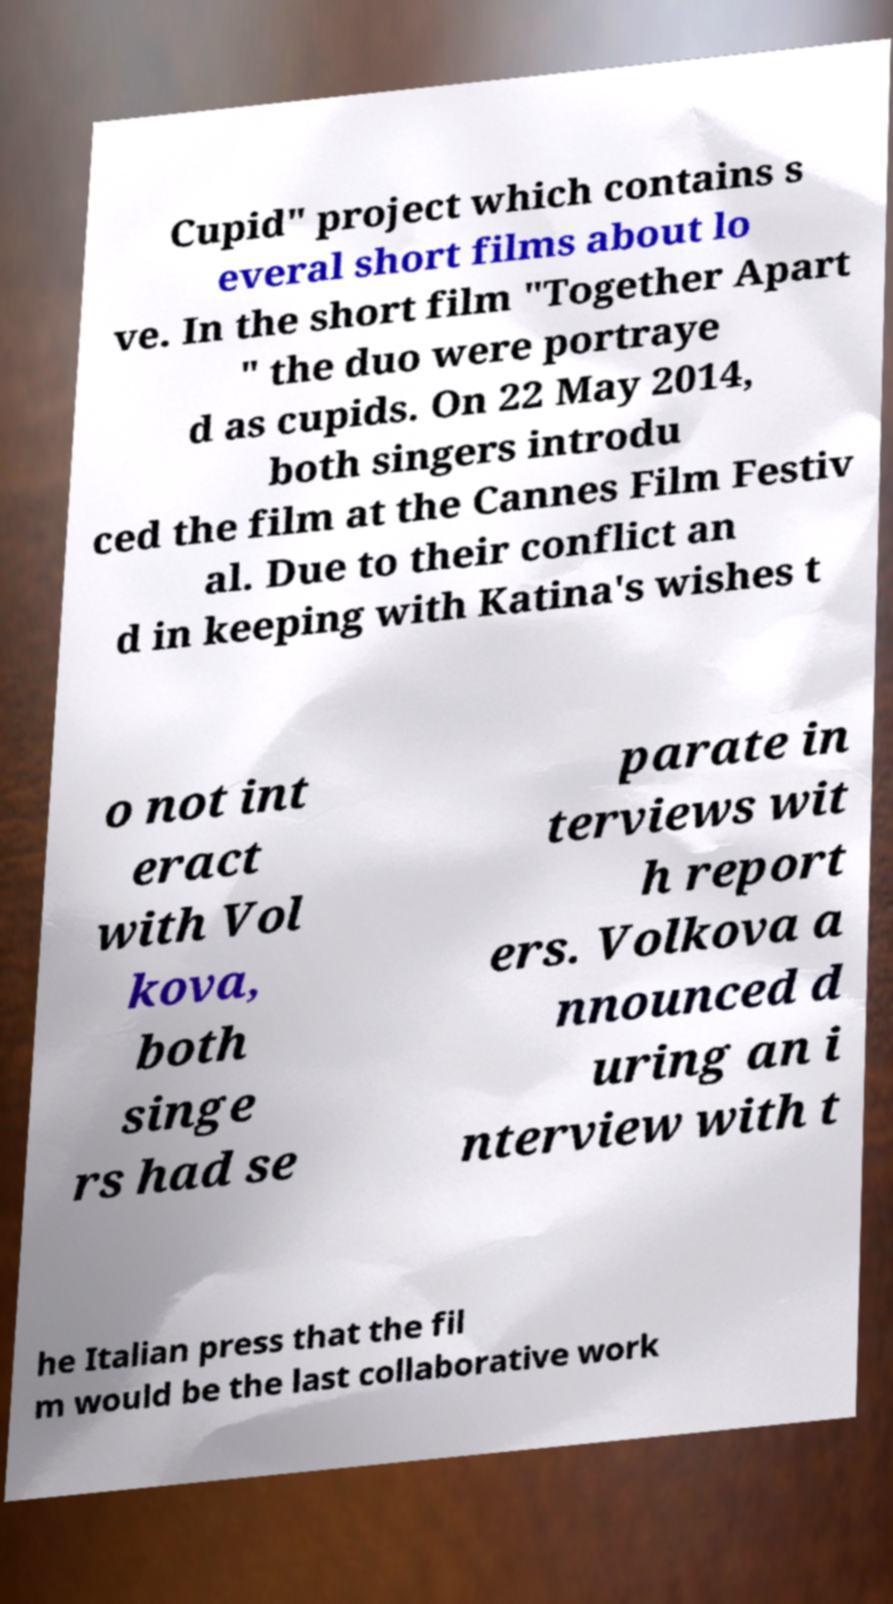Can you read and provide the text displayed in the image?This photo seems to have some interesting text. Can you extract and type it out for me? Cupid" project which contains s everal short films about lo ve. In the short film "Together Apart " the duo were portraye d as cupids. On 22 May 2014, both singers introdu ced the film at the Cannes Film Festiv al. Due to their conflict an d in keeping with Katina's wishes t o not int eract with Vol kova, both singe rs had se parate in terviews wit h report ers. Volkova a nnounced d uring an i nterview with t he Italian press that the fil m would be the last collaborative work 